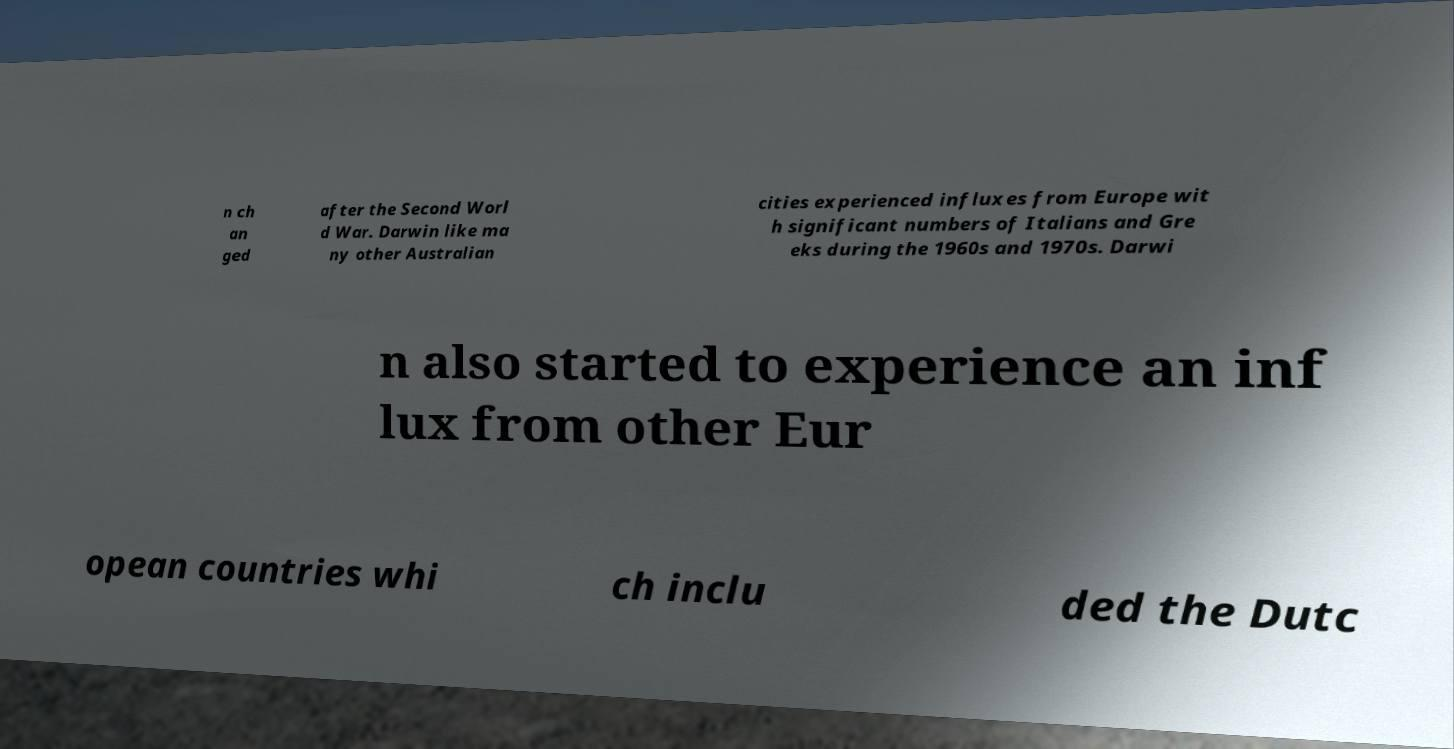Could you extract and type out the text from this image? n ch an ged after the Second Worl d War. Darwin like ma ny other Australian cities experienced influxes from Europe wit h significant numbers of Italians and Gre eks during the 1960s and 1970s. Darwi n also started to experience an inf lux from other Eur opean countries whi ch inclu ded the Dutc 